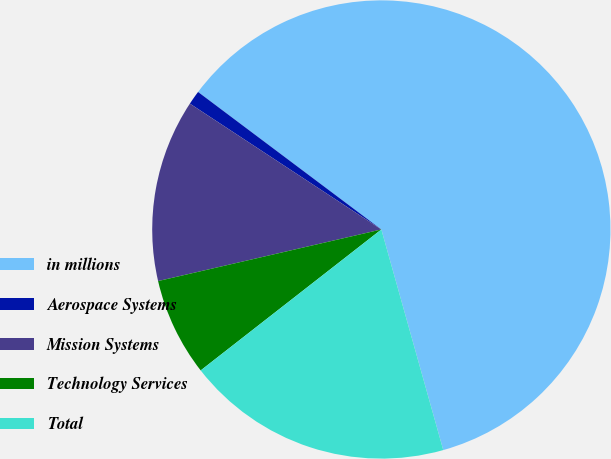Convert chart. <chart><loc_0><loc_0><loc_500><loc_500><pie_chart><fcel>in millions<fcel>Aerospace Systems<fcel>Mission Systems<fcel>Technology Services<fcel>Total<nl><fcel>60.4%<fcel>0.99%<fcel>12.87%<fcel>6.93%<fcel>18.81%<nl></chart> 